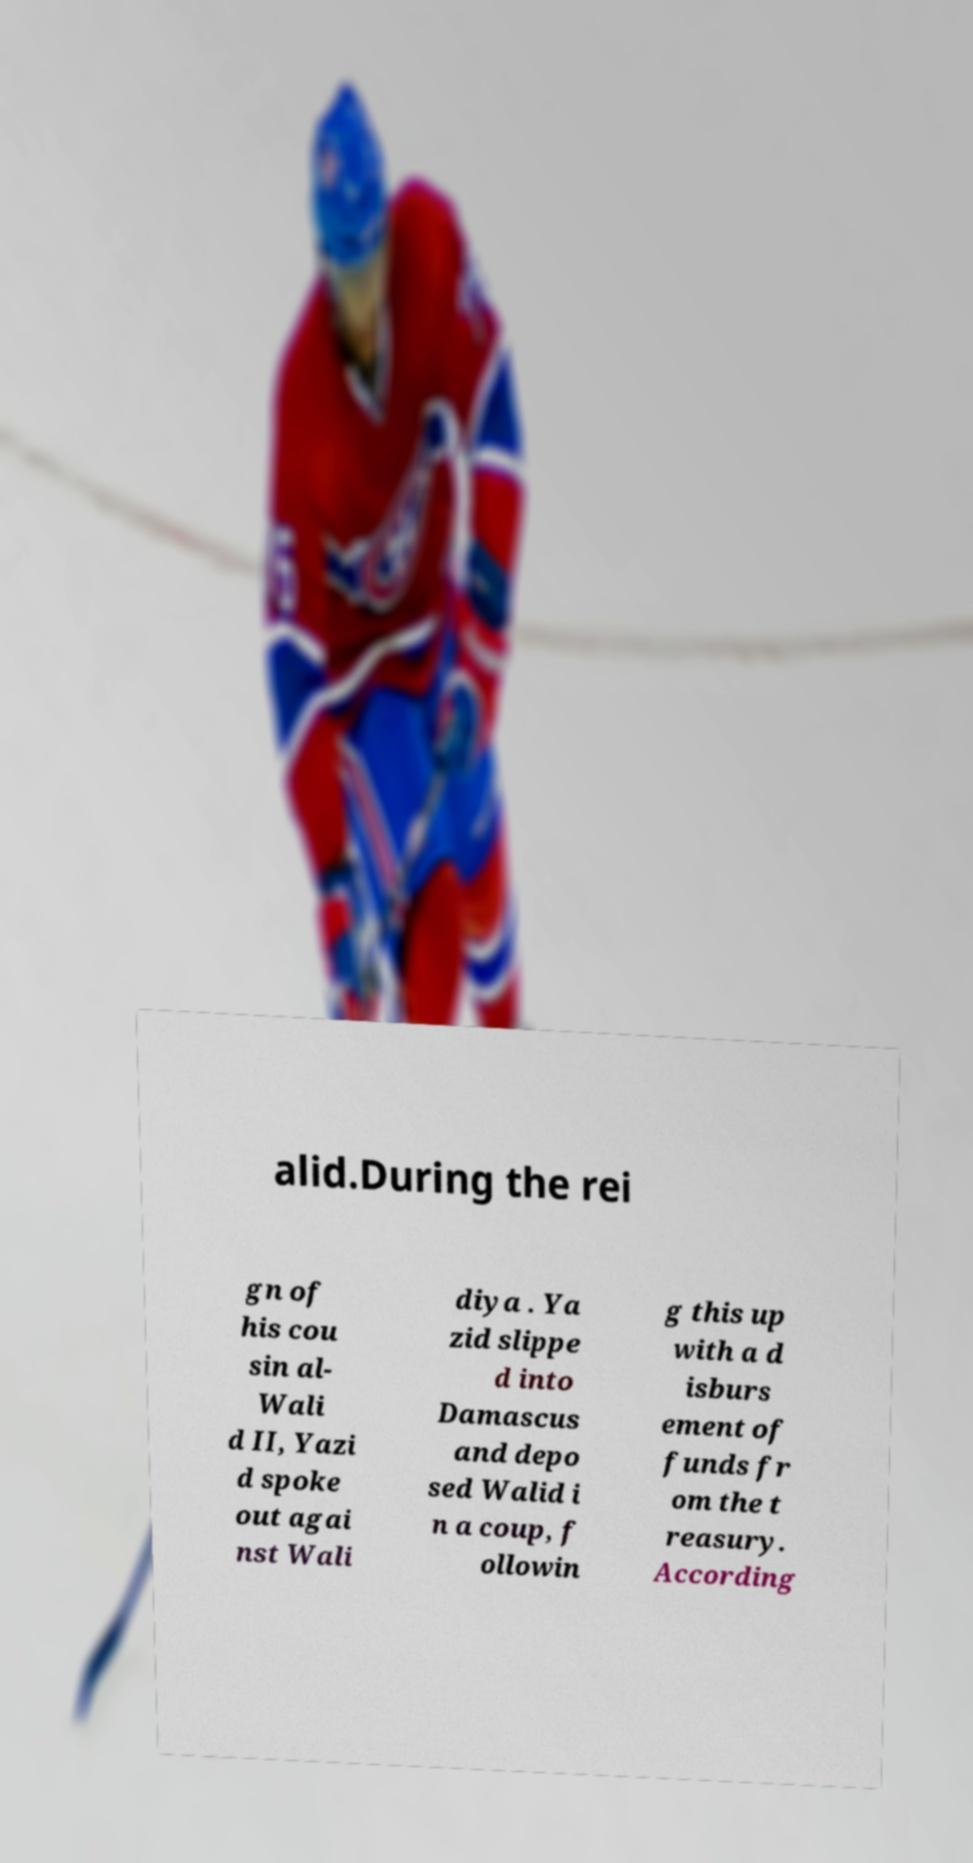Can you accurately transcribe the text from the provided image for me? alid.During the rei gn of his cou sin al- Wali d II, Yazi d spoke out agai nst Wali diya . Ya zid slippe d into Damascus and depo sed Walid i n a coup, f ollowin g this up with a d isburs ement of funds fr om the t reasury. According 